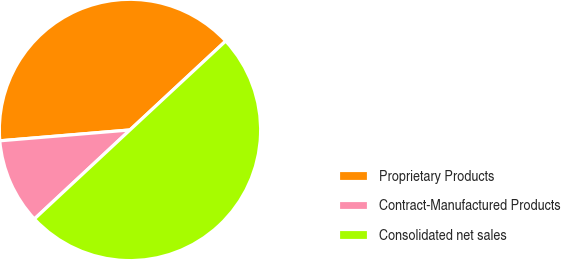Convert chart. <chart><loc_0><loc_0><loc_500><loc_500><pie_chart><fcel>Proprietary Products<fcel>Contract-Manufactured Products<fcel>Consolidated net sales<nl><fcel>39.41%<fcel>10.61%<fcel>49.98%<nl></chart> 